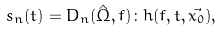Convert formula to latex. <formula><loc_0><loc_0><loc_500><loc_500>s _ { n } ( t ) = D _ { n } ( \hat { \Omega } , f ) \colon h ( f , t , \vec { x _ { 0 } } ) ,</formula> 